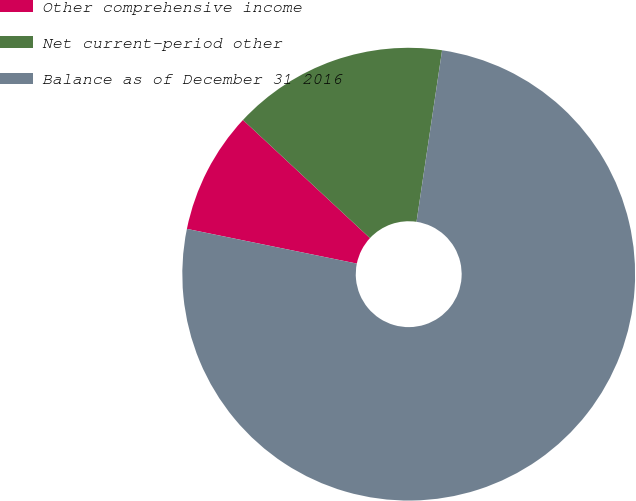Convert chart. <chart><loc_0><loc_0><loc_500><loc_500><pie_chart><fcel>Other comprehensive income<fcel>Net current-period other<fcel>Balance as of December 31 2016<nl><fcel>8.72%<fcel>15.43%<fcel>75.85%<nl></chart> 